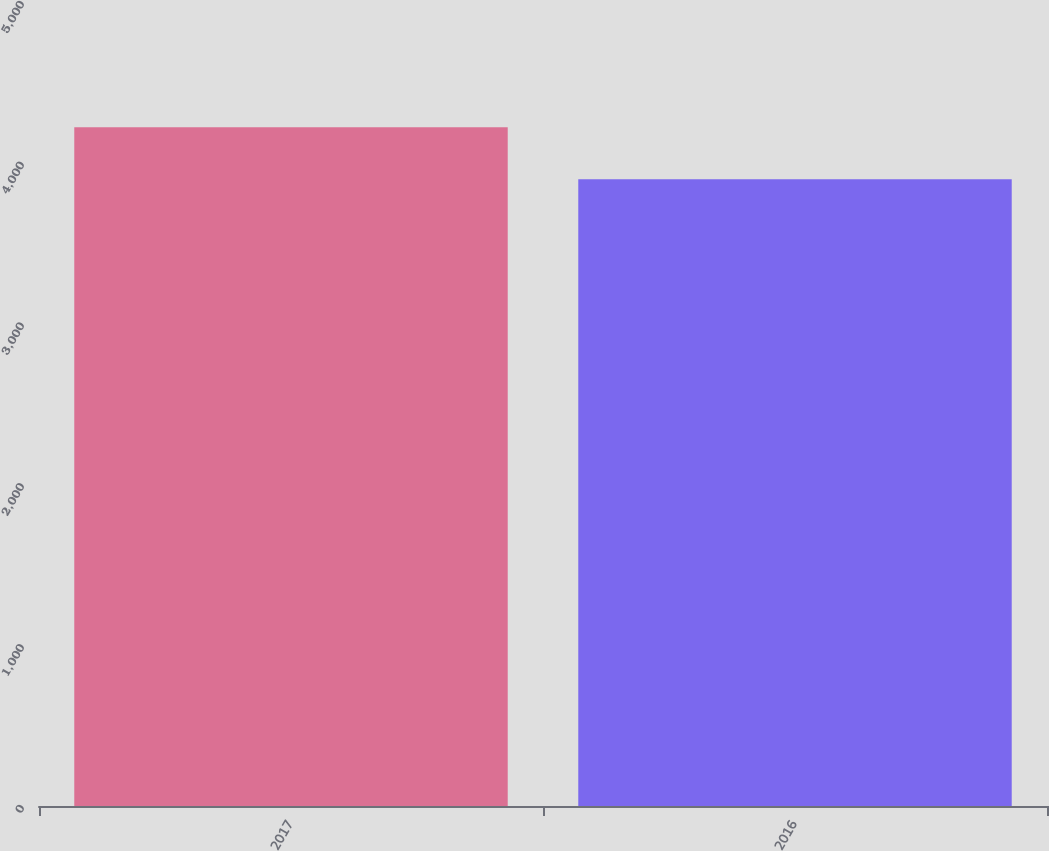Convert chart to OTSL. <chart><loc_0><loc_0><loc_500><loc_500><bar_chart><fcel>2017<fcel>2016<nl><fcel>4221<fcel>3897<nl></chart> 